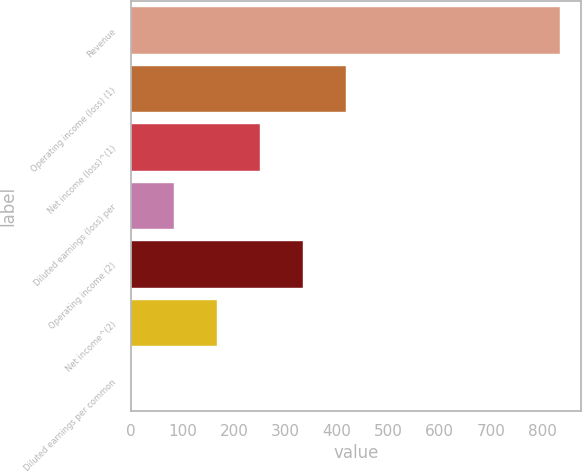Convert chart to OTSL. <chart><loc_0><loc_0><loc_500><loc_500><bar_chart><fcel>Revenue<fcel>Operating income (loss) (1)<fcel>Net income (loss)^(1)<fcel>Diluted earnings (loss) per<fcel>Operating income (2)<fcel>Net income^(2)<fcel>Diluted earnings per common<nl><fcel>834<fcel>417.19<fcel>250.46<fcel>83.72<fcel>333.83<fcel>167.09<fcel>0.35<nl></chart> 